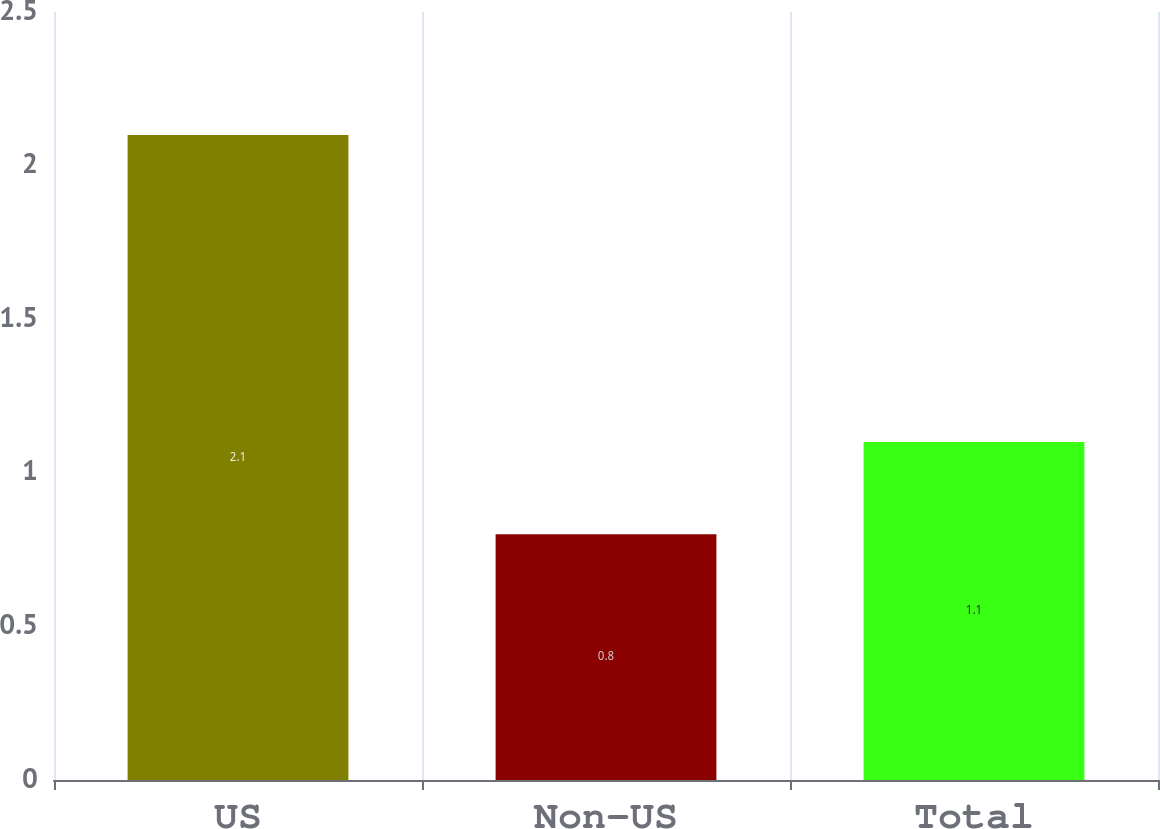Convert chart. <chart><loc_0><loc_0><loc_500><loc_500><bar_chart><fcel>US<fcel>Non-US<fcel>Total<nl><fcel>2.1<fcel>0.8<fcel>1.1<nl></chart> 